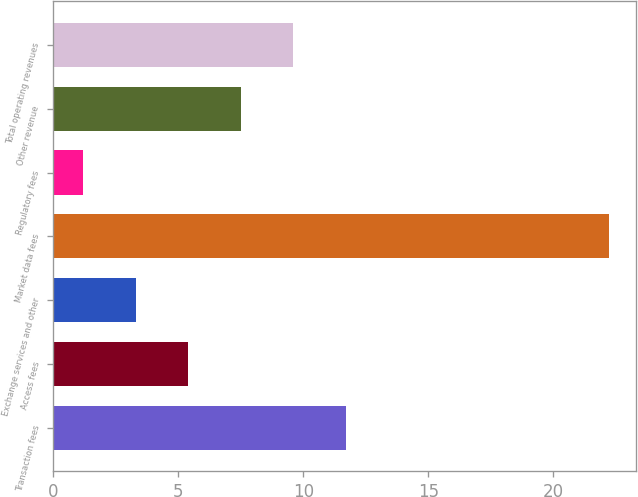<chart> <loc_0><loc_0><loc_500><loc_500><bar_chart><fcel>Transaction fees<fcel>Access fees<fcel>Exchange services and other<fcel>Market data fees<fcel>Regulatory fees<fcel>Other revenue<fcel>Total operating revenues<nl><fcel>11.7<fcel>5.4<fcel>3.3<fcel>22.2<fcel>1.2<fcel>7.5<fcel>9.6<nl></chart> 